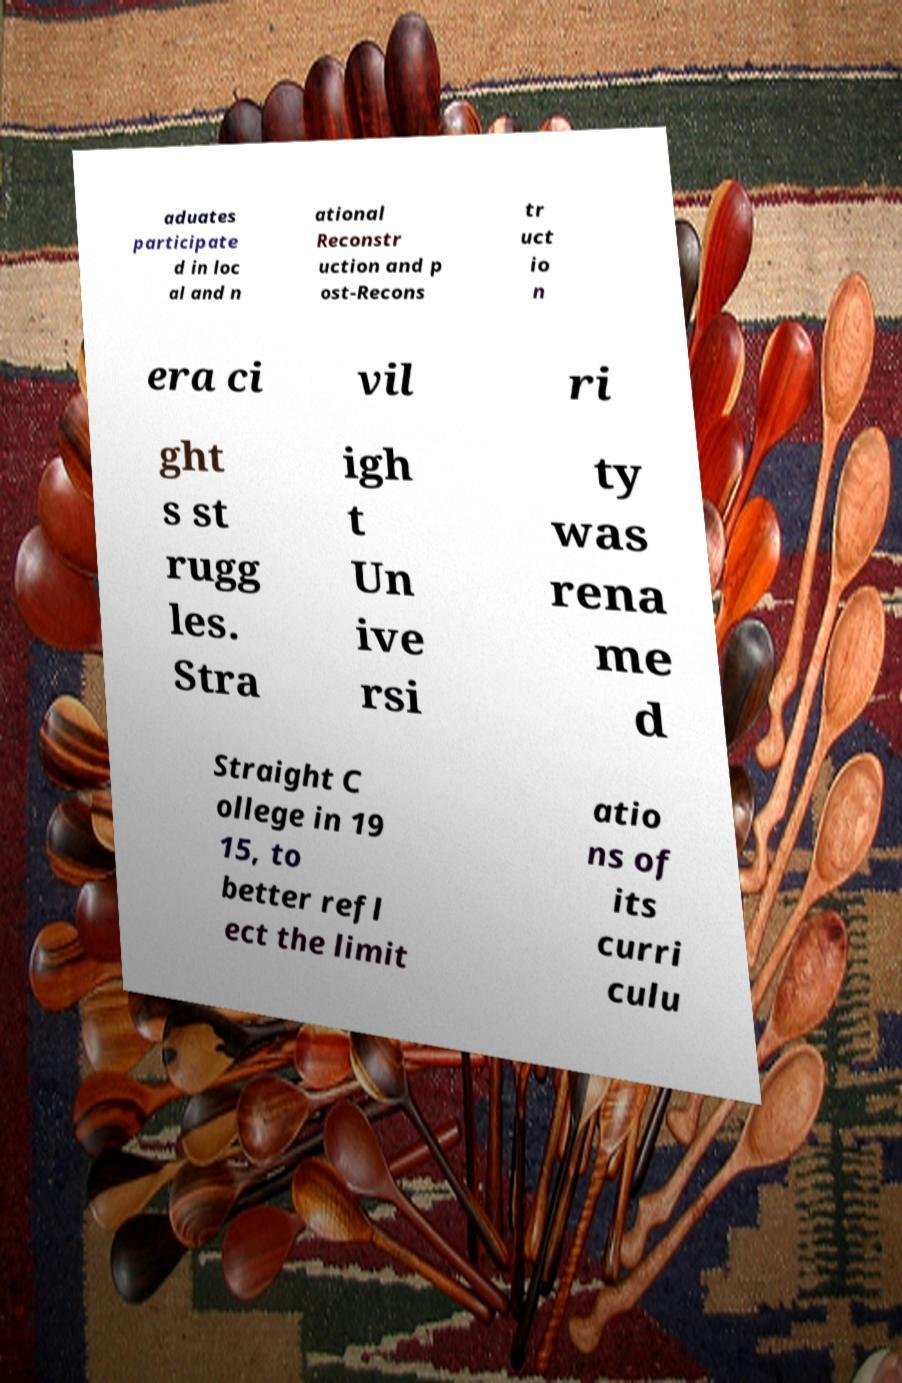What messages or text are displayed in this image? I need them in a readable, typed format. aduates participate d in loc al and n ational Reconstr uction and p ost-Recons tr uct io n era ci vil ri ght s st rugg les. Stra igh t Un ive rsi ty was rena me d Straight C ollege in 19 15, to better refl ect the limit atio ns of its curri culu 